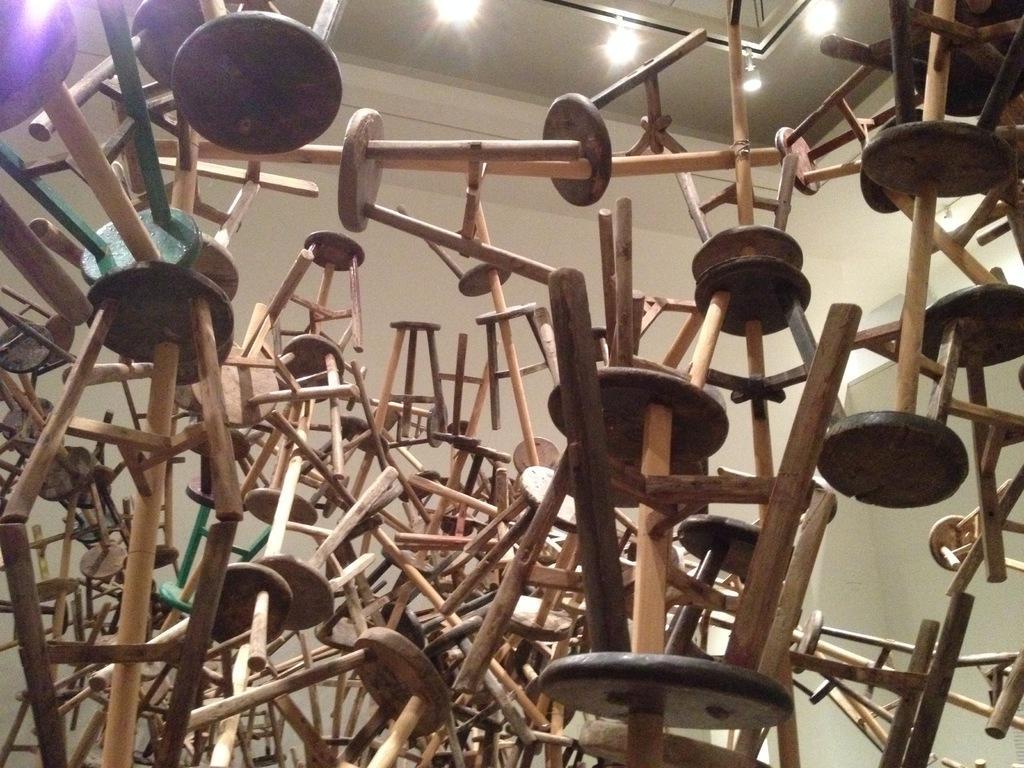Can you describe this image briefly? In this image we can see wooden stools. In the background of the image there is wall. At the top of the image there is ceiling with lights. 